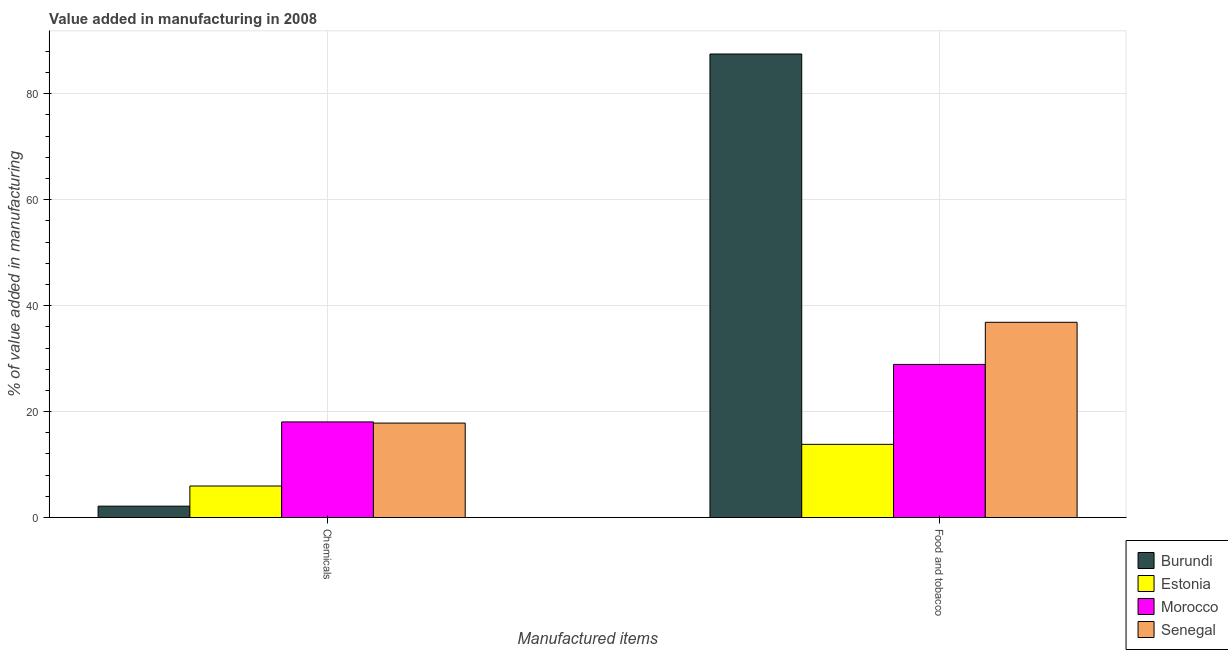How many groups of bars are there?
Your answer should be very brief. 2. Are the number of bars per tick equal to the number of legend labels?
Make the answer very short. Yes. Are the number of bars on each tick of the X-axis equal?
Ensure brevity in your answer.  Yes. How many bars are there on the 2nd tick from the right?
Keep it short and to the point. 4. What is the label of the 2nd group of bars from the left?
Your answer should be very brief. Food and tobacco. What is the value added by  manufacturing chemicals in Morocco?
Offer a terse response. 18.05. Across all countries, what is the maximum value added by  manufacturing chemicals?
Offer a terse response. 18.05. Across all countries, what is the minimum value added by manufacturing food and tobacco?
Your answer should be compact. 13.82. In which country was the value added by manufacturing food and tobacco maximum?
Provide a succinct answer. Burundi. In which country was the value added by manufacturing food and tobacco minimum?
Provide a short and direct response. Estonia. What is the total value added by manufacturing food and tobacco in the graph?
Your answer should be compact. 167.09. What is the difference between the value added by  manufacturing chemicals in Burundi and that in Estonia?
Provide a short and direct response. -3.8. What is the difference between the value added by manufacturing food and tobacco in Estonia and the value added by  manufacturing chemicals in Senegal?
Keep it short and to the point. -4.01. What is the average value added by manufacturing food and tobacco per country?
Your answer should be very brief. 41.77. What is the difference between the value added by  manufacturing chemicals and value added by manufacturing food and tobacco in Morocco?
Your answer should be compact. -10.86. In how many countries, is the value added by  manufacturing chemicals greater than 16 %?
Your response must be concise. 2. What is the ratio of the value added by  manufacturing chemicals in Burundi to that in Estonia?
Offer a terse response. 0.36. What does the 2nd bar from the left in Food and tobacco represents?
Give a very brief answer. Estonia. What does the 2nd bar from the right in Chemicals represents?
Your answer should be compact. Morocco. How many bars are there?
Offer a very short reply. 8. Are the values on the major ticks of Y-axis written in scientific E-notation?
Your answer should be very brief. No. Does the graph contain any zero values?
Make the answer very short. No. How many legend labels are there?
Offer a terse response. 4. What is the title of the graph?
Your response must be concise. Value added in manufacturing in 2008. Does "Estonia" appear as one of the legend labels in the graph?
Make the answer very short. Yes. What is the label or title of the X-axis?
Your response must be concise. Manufactured items. What is the label or title of the Y-axis?
Offer a very short reply. % of value added in manufacturing. What is the % of value added in manufacturing in Burundi in Chemicals?
Make the answer very short. 2.15. What is the % of value added in manufacturing of Estonia in Chemicals?
Offer a very short reply. 5.96. What is the % of value added in manufacturing of Morocco in Chemicals?
Give a very brief answer. 18.05. What is the % of value added in manufacturing in Senegal in Chemicals?
Your response must be concise. 17.83. What is the % of value added in manufacturing of Burundi in Food and tobacco?
Provide a succinct answer. 87.5. What is the % of value added in manufacturing of Estonia in Food and tobacco?
Provide a short and direct response. 13.82. What is the % of value added in manufacturing of Morocco in Food and tobacco?
Offer a very short reply. 28.91. What is the % of value added in manufacturing in Senegal in Food and tobacco?
Your answer should be very brief. 36.86. Across all Manufactured items, what is the maximum % of value added in manufacturing in Burundi?
Make the answer very short. 87.5. Across all Manufactured items, what is the maximum % of value added in manufacturing in Estonia?
Make the answer very short. 13.82. Across all Manufactured items, what is the maximum % of value added in manufacturing in Morocco?
Provide a succinct answer. 28.91. Across all Manufactured items, what is the maximum % of value added in manufacturing of Senegal?
Your answer should be very brief. 36.86. Across all Manufactured items, what is the minimum % of value added in manufacturing in Burundi?
Offer a very short reply. 2.15. Across all Manufactured items, what is the minimum % of value added in manufacturing of Estonia?
Give a very brief answer. 5.96. Across all Manufactured items, what is the minimum % of value added in manufacturing of Morocco?
Your answer should be very brief. 18.05. Across all Manufactured items, what is the minimum % of value added in manufacturing of Senegal?
Offer a very short reply. 17.83. What is the total % of value added in manufacturing of Burundi in the graph?
Ensure brevity in your answer.  89.66. What is the total % of value added in manufacturing in Estonia in the graph?
Your answer should be compact. 19.78. What is the total % of value added in manufacturing in Morocco in the graph?
Your answer should be compact. 46.96. What is the total % of value added in manufacturing in Senegal in the graph?
Your answer should be compact. 54.69. What is the difference between the % of value added in manufacturing of Burundi in Chemicals and that in Food and tobacco?
Your response must be concise. -85.35. What is the difference between the % of value added in manufacturing of Estonia in Chemicals and that in Food and tobacco?
Your answer should be very brief. -7.86. What is the difference between the % of value added in manufacturing in Morocco in Chemicals and that in Food and tobacco?
Your response must be concise. -10.86. What is the difference between the % of value added in manufacturing in Senegal in Chemicals and that in Food and tobacco?
Your answer should be compact. -19.03. What is the difference between the % of value added in manufacturing of Burundi in Chemicals and the % of value added in manufacturing of Estonia in Food and tobacco?
Provide a short and direct response. -11.67. What is the difference between the % of value added in manufacturing in Burundi in Chemicals and the % of value added in manufacturing in Morocco in Food and tobacco?
Offer a very short reply. -26.76. What is the difference between the % of value added in manufacturing in Burundi in Chemicals and the % of value added in manufacturing in Senegal in Food and tobacco?
Your answer should be very brief. -34.7. What is the difference between the % of value added in manufacturing in Estonia in Chemicals and the % of value added in manufacturing in Morocco in Food and tobacco?
Provide a succinct answer. -22.95. What is the difference between the % of value added in manufacturing in Estonia in Chemicals and the % of value added in manufacturing in Senegal in Food and tobacco?
Offer a very short reply. -30.9. What is the difference between the % of value added in manufacturing in Morocco in Chemicals and the % of value added in manufacturing in Senegal in Food and tobacco?
Provide a short and direct response. -18.81. What is the average % of value added in manufacturing in Burundi per Manufactured items?
Make the answer very short. 44.83. What is the average % of value added in manufacturing of Estonia per Manufactured items?
Give a very brief answer. 9.89. What is the average % of value added in manufacturing in Morocco per Manufactured items?
Offer a very short reply. 23.48. What is the average % of value added in manufacturing in Senegal per Manufactured items?
Ensure brevity in your answer.  27.35. What is the difference between the % of value added in manufacturing of Burundi and % of value added in manufacturing of Estonia in Chemicals?
Keep it short and to the point. -3.8. What is the difference between the % of value added in manufacturing of Burundi and % of value added in manufacturing of Morocco in Chemicals?
Offer a terse response. -15.9. What is the difference between the % of value added in manufacturing of Burundi and % of value added in manufacturing of Senegal in Chemicals?
Offer a very short reply. -15.68. What is the difference between the % of value added in manufacturing of Estonia and % of value added in manufacturing of Morocco in Chemicals?
Provide a short and direct response. -12.1. What is the difference between the % of value added in manufacturing of Estonia and % of value added in manufacturing of Senegal in Chemicals?
Keep it short and to the point. -11.88. What is the difference between the % of value added in manufacturing of Morocco and % of value added in manufacturing of Senegal in Chemicals?
Give a very brief answer. 0.22. What is the difference between the % of value added in manufacturing of Burundi and % of value added in manufacturing of Estonia in Food and tobacco?
Offer a terse response. 73.68. What is the difference between the % of value added in manufacturing in Burundi and % of value added in manufacturing in Morocco in Food and tobacco?
Your answer should be compact. 58.59. What is the difference between the % of value added in manufacturing of Burundi and % of value added in manufacturing of Senegal in Food and tobacco?
Provide a short and direct response. 50.64. What is the difference between the % of value added in manufacturing in Estonia and % of value added in manufacturing in Morocco in Food and tobacco?
Make the answer very short. -15.09. What is the difference between the % of value added in manufacturing in Estonia and % of value added in manufacturing in Senegal in Food and tobacco?
Offer a very short reply. -23.04. What is the difference between the % of value added in manufacturing of Morocco and % of value added in manufacturing of Senegal in Food and tobacco?
Your answer should be compact. -7.95. What is the ratio of the % of value added in manufacturing of Burundi in Chemicals to that in Food and tobacco?
Provide a succinct answer. 0.02. What is the ratio of the % of value added in manufacturing in Estonia in Chemicals to that in Food and tobacco?
Provide a short and direct response. 0.43. What is the ratio of the % of value added in manufacturing of Morocco in Chemicals to that in Food and tobacco?
Your response must be concise. 0.62. What is the ratio of the % of value added in manufacturing of Senegal in Chemicals to that in Food and tobacco?
Your response must be concise. 0.48. What is the difference between the highest and the second highest % of value added in manufacturing in Burundi?
Make the answer very short. 85.35. What is the difference between the highest and the second highest % of value added in manufacturing of Estonia?
Your answer should be very brief. 7.86. What is the difference between the highest and the second highest % of value added in manufacturing in Morocco?
Your answer should be compact. 10.86. What is the difference between the highest and the second highest % of value added in manufacturing in Senegal?
Your answer should be very brief. 19.03. What is the difference between the highest and the lowest % of value added in manufacturing in Burundi?
Make the answer very short. 85.35. What is the difference between the highest and the lowest % of value added in manufacturing in Estonia?
Provide a succinct answer. 7.86. What is the difference between the highest and the lowest % of value added in manufacturing of Morocco?
Ensure brevity in your answer.  10.86. What is the difference between the highest and the lowest % of value added in manufacturing in Senegal?
Provide a succinct answer. 19.03. 